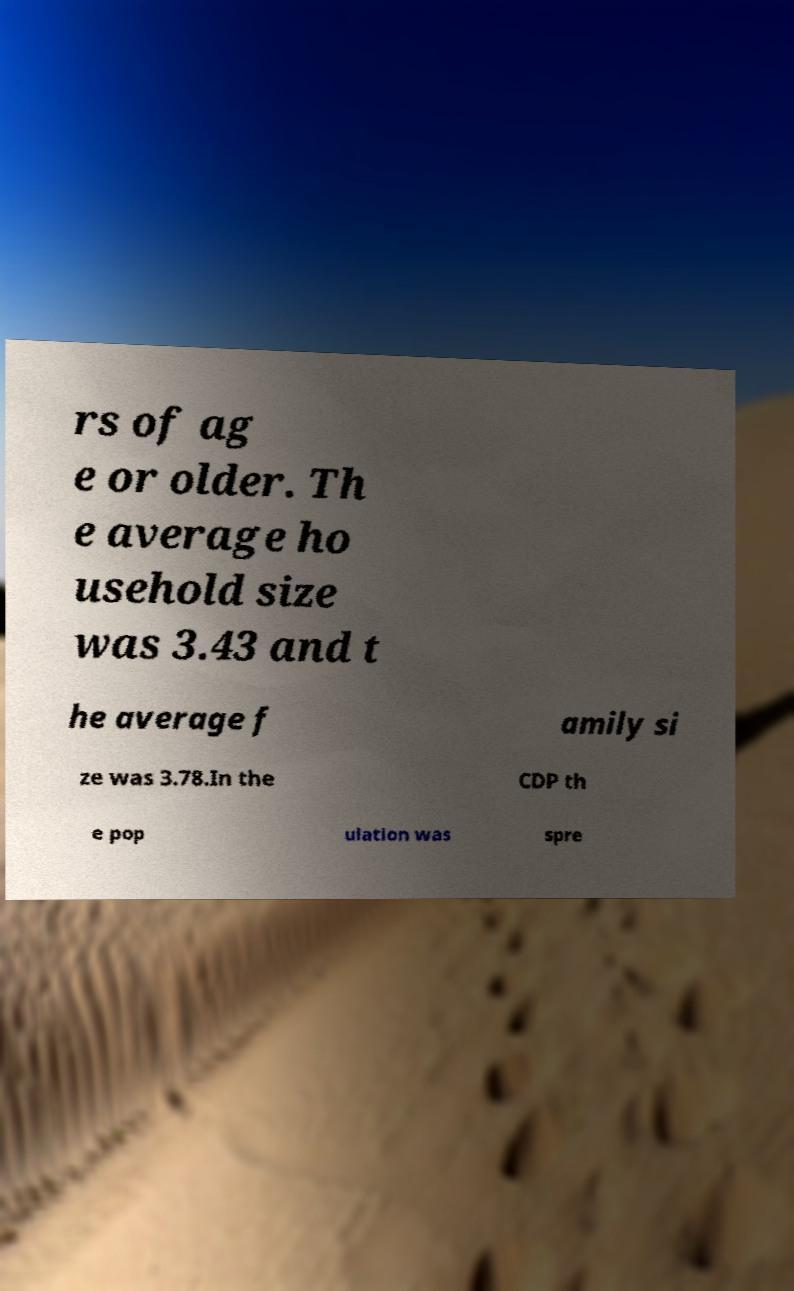I need the written content from this picture converted into text. Can you do that? rs of ag e or older. Th e average ho usehold size was 3.43 and t he average f amily si ze was 3.78.In the CDP th e pop ulation was spre 